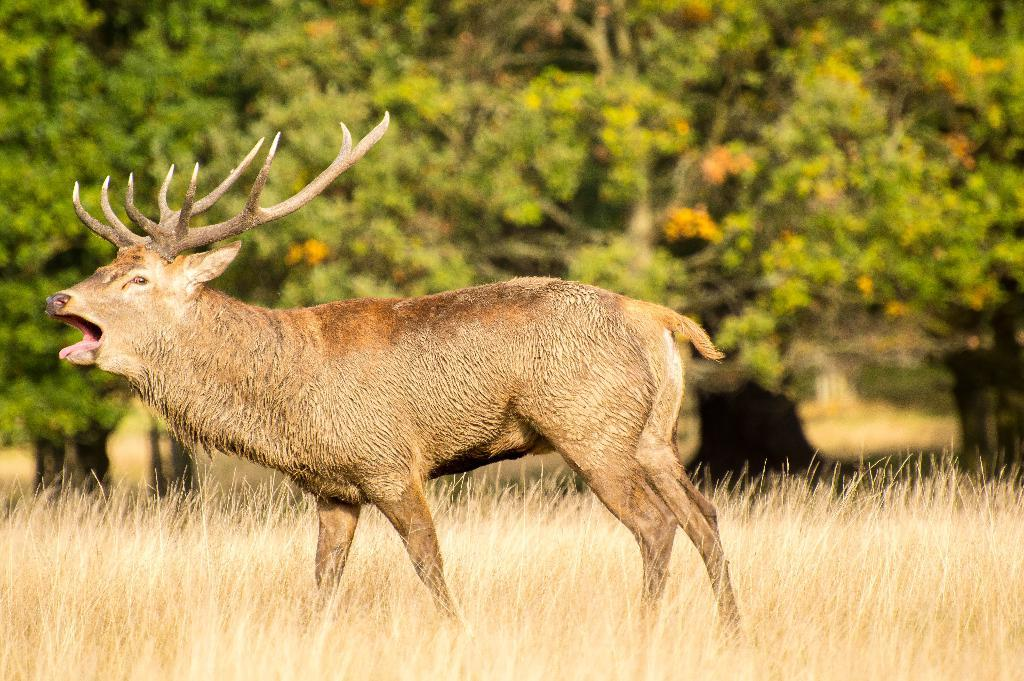What type of environment might the image be taken from? The image might be taken from a forest. What is the main subject in the middle of the image? There is an animal in the middle of the image. What can be seen in the background of the image? There are trees in the background of the image. What type of vegetation is visible at the bottom of the image? There is grass at the bottom of the image. Can you see the animal smiling in the image? There is no indication of the animal's facial expression in the image, so it cannot be determined if the animal is smiling. 